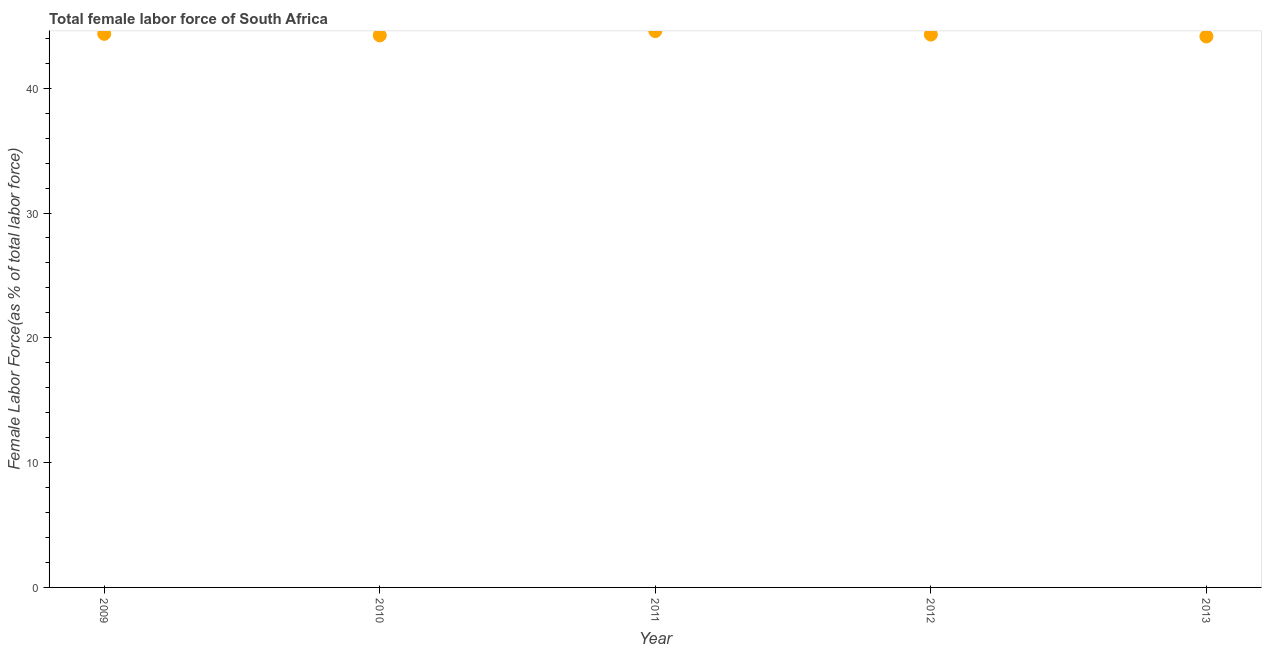What is the total female labor force in 2010?
Offer a terse response. 44.23. Across all years, what is the maximum total female labor force?
Give a very brief answer. 44.58. Across all years, what is the minimum total female labor force?
Ensure brevity in your answer.  44.15. In which year was the total female labor force maximum?
Your answer should be very brief. 2011. In which year was the total female labor force minimum?
Ensure brevity in your answer.  2013. What is the sum of the total female labor force?
Your answer should be compact. 221.62. What is the difference between the total female labor force in 2010 and 2011?
Offer a very short reply. -0.34. What is the average total female labor force per year?
Offer a terse response. 44.32. What is the median total female labor force?
Make the answer very short. 44.3. What is the ratio of the total female labor force in 2012 to that in 2013?
Your response must be concise. 1. What is the difference between the highest and the second highest total female labor force?
Your answer should be compact. 0.22. What is the difference between the highest and the lowest total female labor force?
Offer a terse response. 0.43. In how many years, is the total female labor force greater than the average total female labor force taken over all years?
Your response must be concise. 2. How many dotlines are there?
Provide a succinct answer. 1. What is the difference between two consecutive major ticks on the Y-axis?
Provide a short and direct response. 10. Does the graph contain grids?
Give a very brief answer. No. What is the title of the graph?
Make the answer very short. Total female labor force of South Africa. What is the label or title of the X-axis?
Give a very brief answer. Year. What is the label or title of the Y-axis?
Offer a terse response. Female Labor Force(as % of total labor force). What is the Female Labor Force(as % of total labor force) in 2009?
Your answer should be very brief. 44.36. What is the Female Labor Force(as % of total labor force) in 2010?
Your answer should be compact. 44.23. What is the Female Labor Force(as % of total labor force) in 2011?
Keep it short and to the point. 44.58. What is the Female Labor Force(as % of total labor force) in 2012?
Your answer should be compact. 44.3. What is the Female Labor Force(as % of total labor force) in 2013?
Give a very brief answer. 44.15. What is the difference between the Female Labor Force(as % of total labor force) in 2009 and 2010?
Provide a short and direct response. 0.12. What is the difference between the Female Labor Force(as % of total labor force) in 2009 and 2011?
Ensure brevity in your answer.  -0.22. What is the difference between the Female Labor Force(as % of total labor force) in 2009 and 2012?
Your answer should be very brief. 0.06. What is the difference between the Female Labor Force(as % of total labor force) in 2009 and 2013?
Ensure brevity in your answer.  0.21. What is the difference between the Female Labor Force(as % of total labor force) in 2010 and 2011?
Make the answer very short. -0.34. What is the difference between the Female Labor Force(as % of total labor force) in 2010 and 2012?
Provide a succinct answer. -0.06. What is the difference between the Female Labor Force(as % of total labor force) in 2010 and 2013?
Offer a terse response. 0.09. What is the difference between the Female Labor Force(as % of total labor force) in 2011 and 2012?
Ensure brevity in your answer.  0.28. What is the difference between the Female Labor Force(as % of total labor force) in 2011 and 2013?
Offer a very short reply. 0.43. What is the difference between the Female Labor Force(as % of total labor force) in 2012 and 2013?
Keep it short and to the point. 0.15. What is the ratio of the Female Labor Force(as % of total labor force) in 2009 to that in 2011?
Your answer should be very brief. 0.99. What is the ratio of the Female Labor Force(as % of total labor force) in 2010 to that in 2013?
Give a very brief answer. 1. What is the ratio of the Female Labor Force(as % of total labor force) in 2011 to that in 2012?
Your answer should be compact. 1.01. What is the ratio of the Female Labor Force(as % of total labor force) in 2012 to that in 2013?
Your answer should be very brief. 1. 